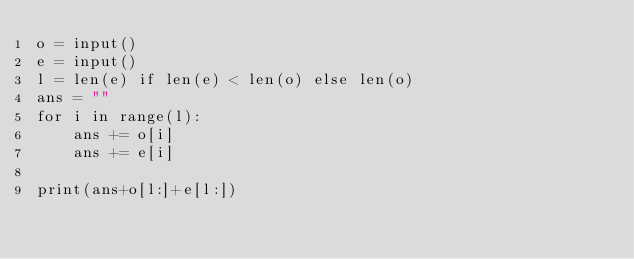Convert code to text. <code><loc_0><loc_0><loc_500><loc_500><_Python_>o = input()
e = input()
l = len(e) if len(e) < len(o) else len(o)
ans = ""
for i in range(l):
    ans += o[i]
    ans += e[i]

print(ans+o[l:]+e[l:])</code> 